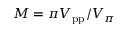Convert formula to latex. <formula><loc_0><loc_0><loc_500><loc_500>M = \pi V _ { p p } / V _ { \pi }</formula> 